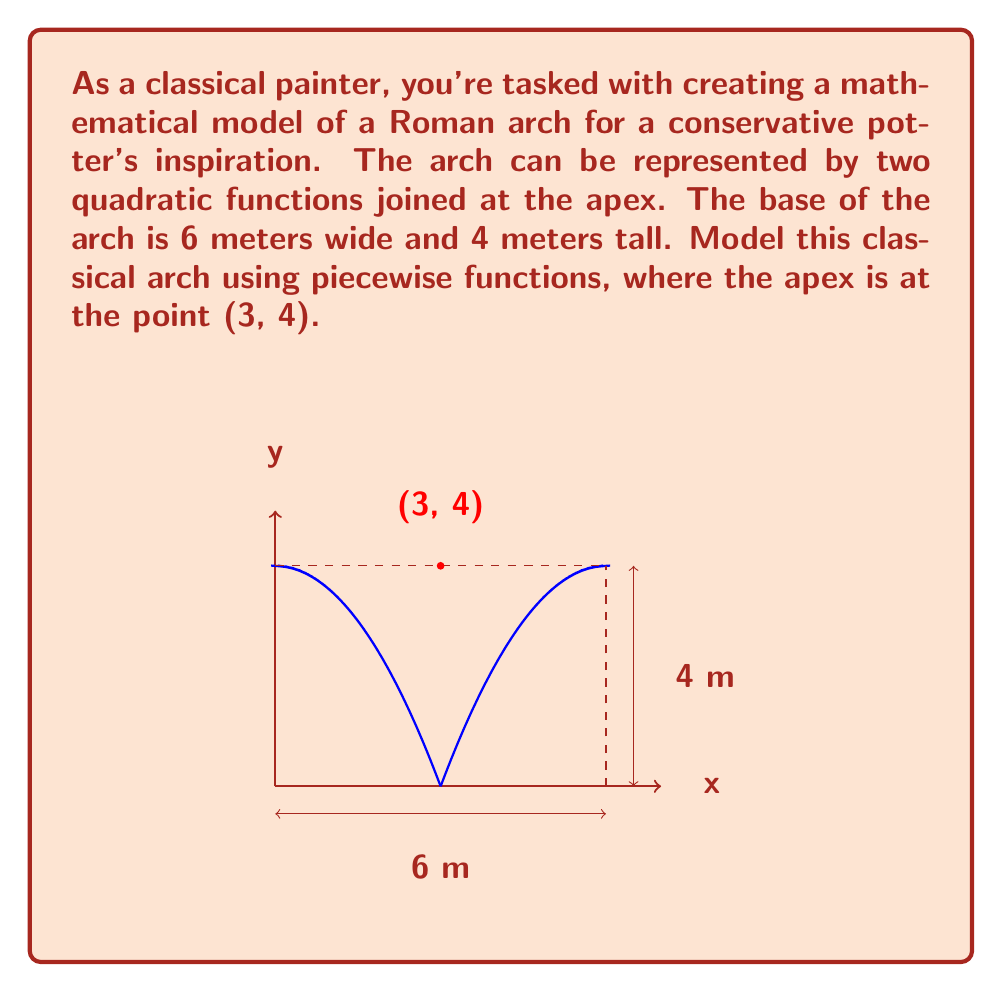Show me your answer to this math problem. Let's approach this step-by-step:

1) We need two quadratic functions of the form $f(x) = a(x-h)^2 + k$, where (h,k) is the vertex.

2) For the left side of the arch:
   - The vertex is at (3,4)
   - The function passes through (0,0)

3) Let's use the general form: $f_1(x) = a(x-3)^2 + 4$

4) To find $a$, use the point (0,0):
   $0 = a(0-3)^2 + 4$
   $-4 = 9a$
   $a = -\frac{4}{9}$

5) So, the left side function is: $f_1(x) = -\frac{4}{9}(x-3)^2 + 4$

6) For the right side, we can mirror this function:
   $f_2(x) = -\frac{4}{9}(x-3)^2 + 4$, but shifted 6 units to the right
   $f_2(x) = -\frac{4}{9}((x-6)-3)^2 + 4 = -\frac{4}{9}(x-9)^2 + 4$

7) Our piecewise function is:

   $$f(x) = \begin{cases} 
   -\frac{4}{9}(x-3)^2 + 4, & 0 \leq x \leq 3 \\
   -\frac{4}{9}(x-9)^2 + 4, & 3 < x \leq 6
   \end{cases}$$

This piecewise function models the classical Roman arch.
Answer: $$f(x) = \begin{cases} 
-\frac{4}{9}(x-3)^2 + 4, & 0 \leq x \leq 3 \\
-\frac{4}{9}(x-9)^2 + 4, & 3 < x \leq 6
\end{cases}$$ 